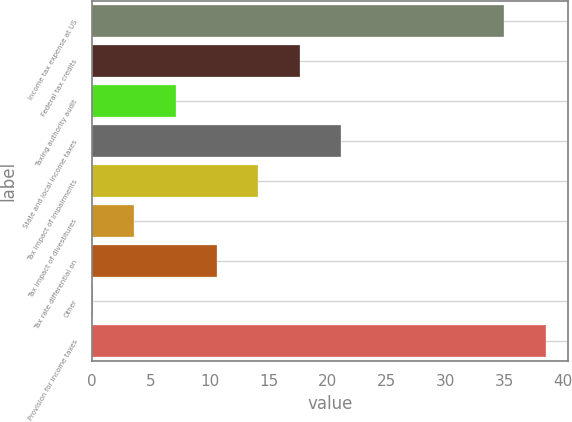<chart> <loc_0><loc_0><loc_500><loc_500><bar_chart><fcel>Income tax expense at US<fcel>Federal tax credits<fcel>Taxing authority audit<fcel>State and local income taxes<fcel>Tax impact of impairments<fcel>Tax impact of divestitures<fcel>Tax rate differential on<fcel>Other<fcel>Provision for income taxes<nl><fcel>35<fcel>17.65<fcel>7.12<fcel>21.16<fcel>14.14<fcel>3.61<fcel>10.63<fcel>0.1<fcel>38.51<nl></chart> 